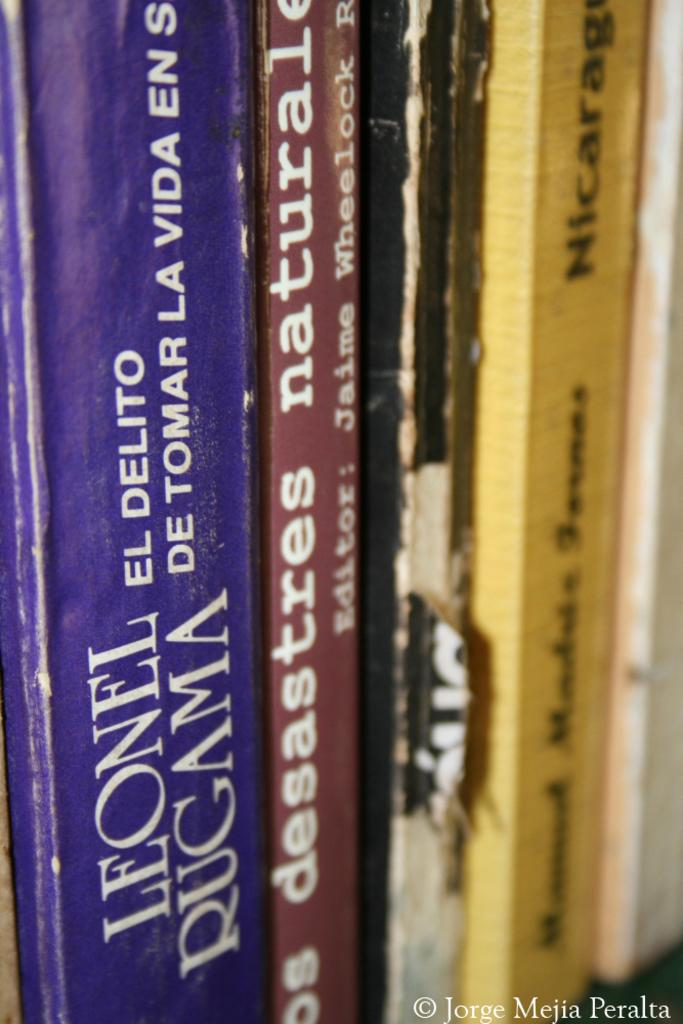<image>
Describe the image concisely. A number of books are lined up on a shelf, including one by Leonel Rugama. 